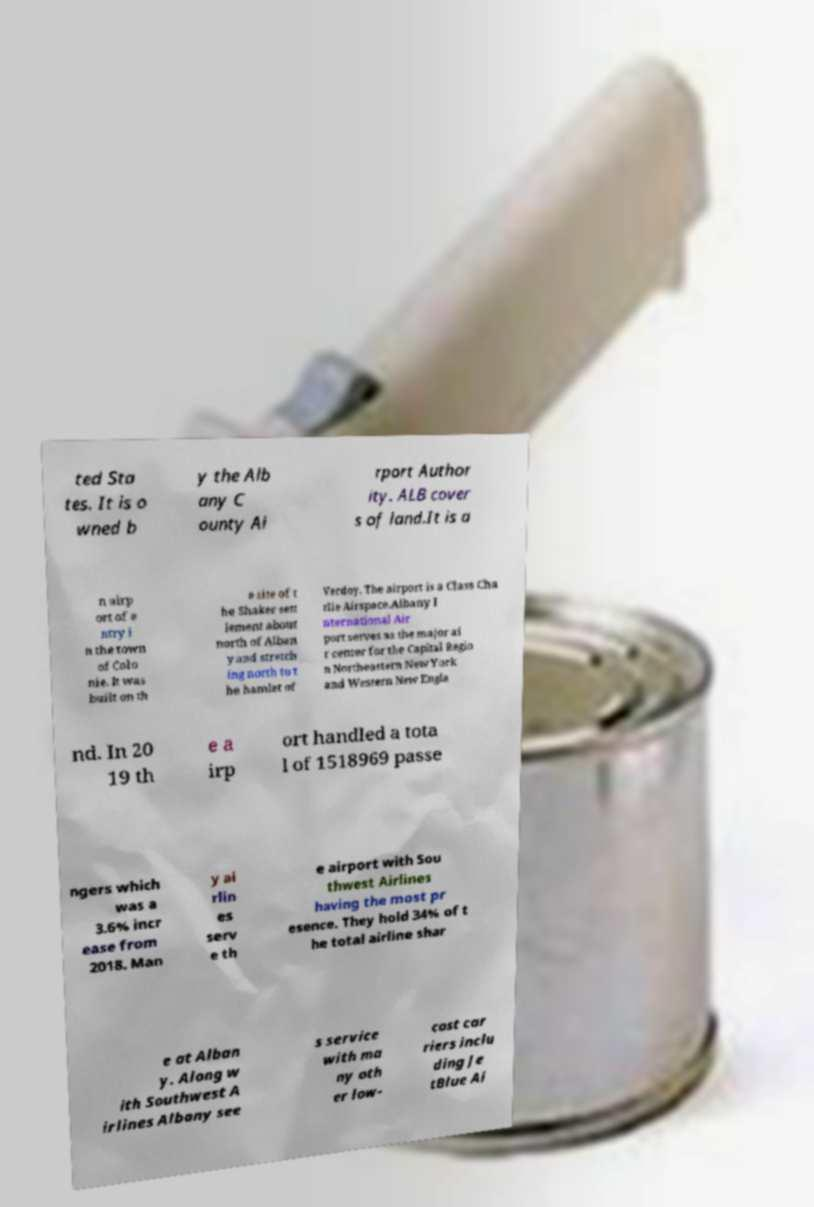For documentation purposes, I need the text within this image transcribed. Could you provide that? ted Sta tes. It is o wned b y the Alb any C ounty Ai rport Author ity. ALB cover s of land.It is a n airp ort of e ntry i n the town of Colo nie. It was built on th e site of t he Shaker sett lement about north of Alban y and stretch ing north to t he hamlet of Verdoy. The airport is a Class Cha rlie Airspace.Albany I nternational Air port serves as the major ai r center for the Capital Regio n Northeastern New York and Western New Engla nd. In 20 19 th e a irp ort handled a tota l of 1518969 passe ngers which was a 3.6% incr ease from 2018. Man y ai rlin es serv e th e airport with Sou thwest Airlines having the most pr esence. They hold 34% of t he total airline shar e at Alban y. Along w ith Southwest A irlines Albany see s service with ma ny oth er low- cost car riers inclu ding Je tBlue Ai 